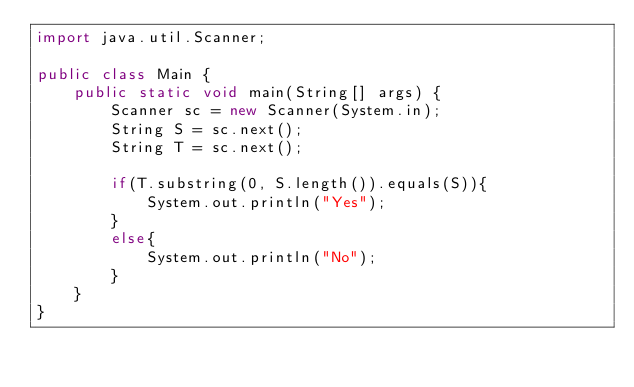<code> <loc_0><loc_0><loc_500><loc_500><_Java_>import java.util.Scanner;

public class Main {
    public static void main(String[] args) {
        Scanner sc = new Scanner(System.in);
        String S = sc.next();
        String T = sc.next();
        
        if(T.substring(0, S.length()).equals(S)){
            System.out.println("Yes");
        }
        else{
            System.out.println("No");
        }
    }
}</code> 